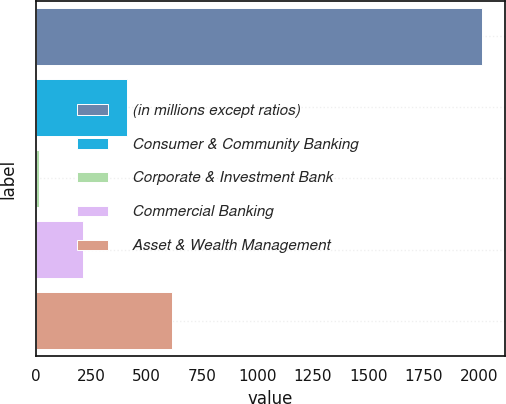Convert chart to OTSL. <chart><loc_0><loc_0><loc_500><loc_500><bar_chart><fcel>(in millions except ratios)<fcel>Consumer & Community Banking<fcel>Corporate & Investment Bank<fcel>Commercial Banking<fcel>Asset & Wealth Management<nl><fcel>2015<fcel>412.6<fcel>12<fcel>212.3<fcel>612.9<nl></chart> 